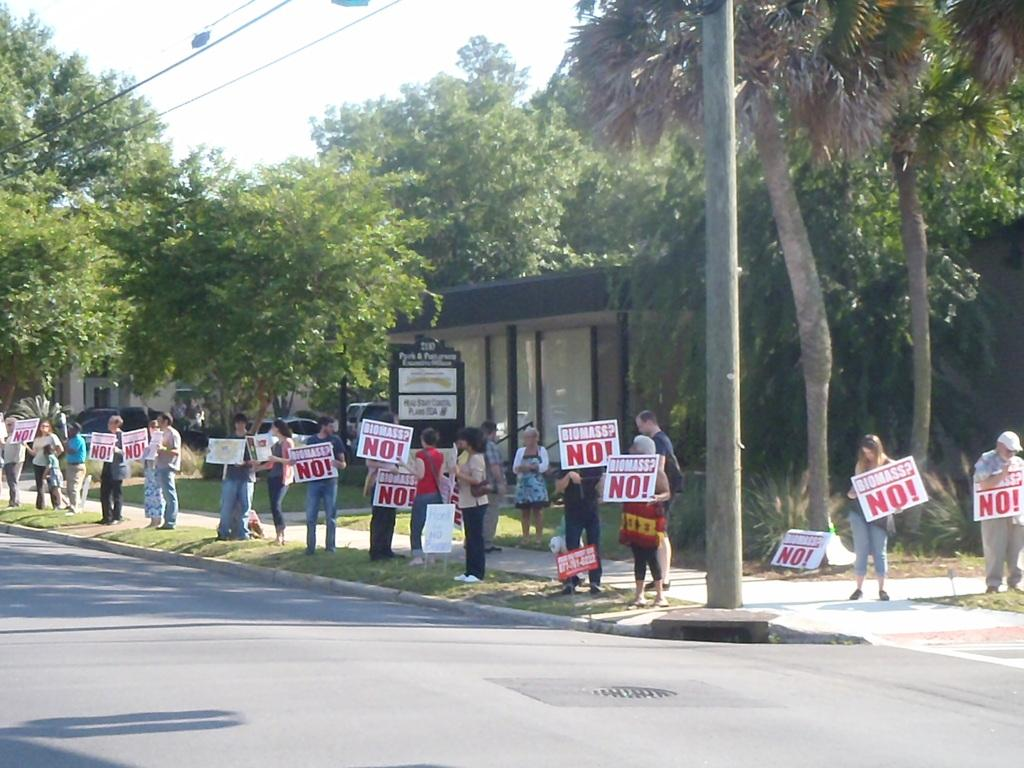<image>
Describe the image concisely. People protesting with signs that say Biomass? NO 